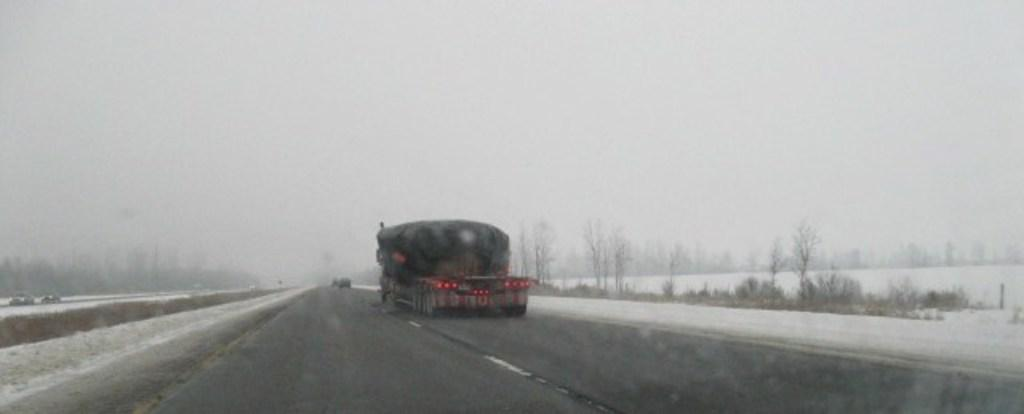What is happening on the road in the image? There are vehicles on a road in the image. What is the weather like in the image? There is snow visible in the image, indicating a snowy or wintry scene. What type of vegetation is present on either side of the road? There are trees on either side of the road in the image. What is visible at the top of the image? The sky is visible at the top of the image. Can you tell me what type of fuel the doctor is using to play with the vehicles in the image? There is no doctor or fuel present in the image, and the vehicles are not being played with. 